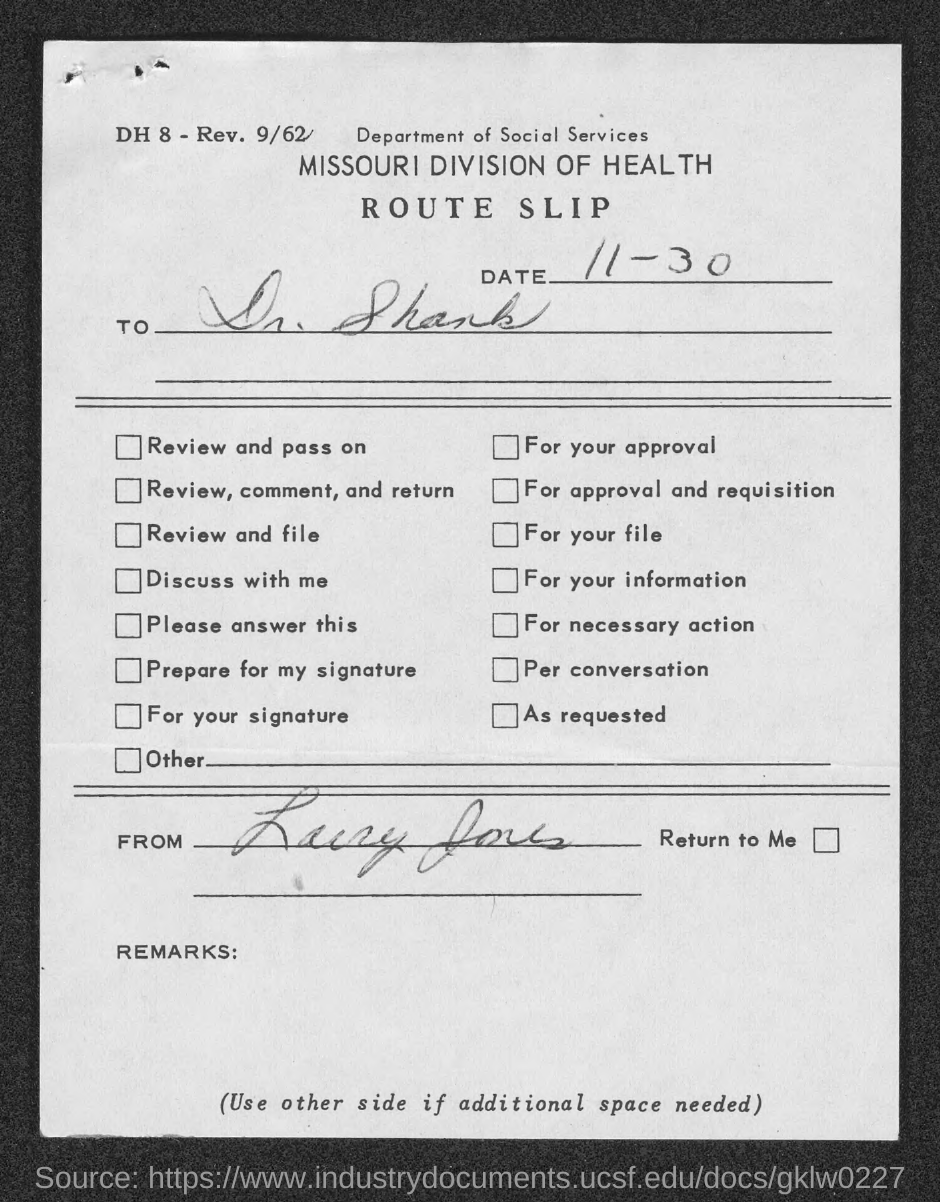When is the route slip dated?
Your response must be concise. 11-30. 